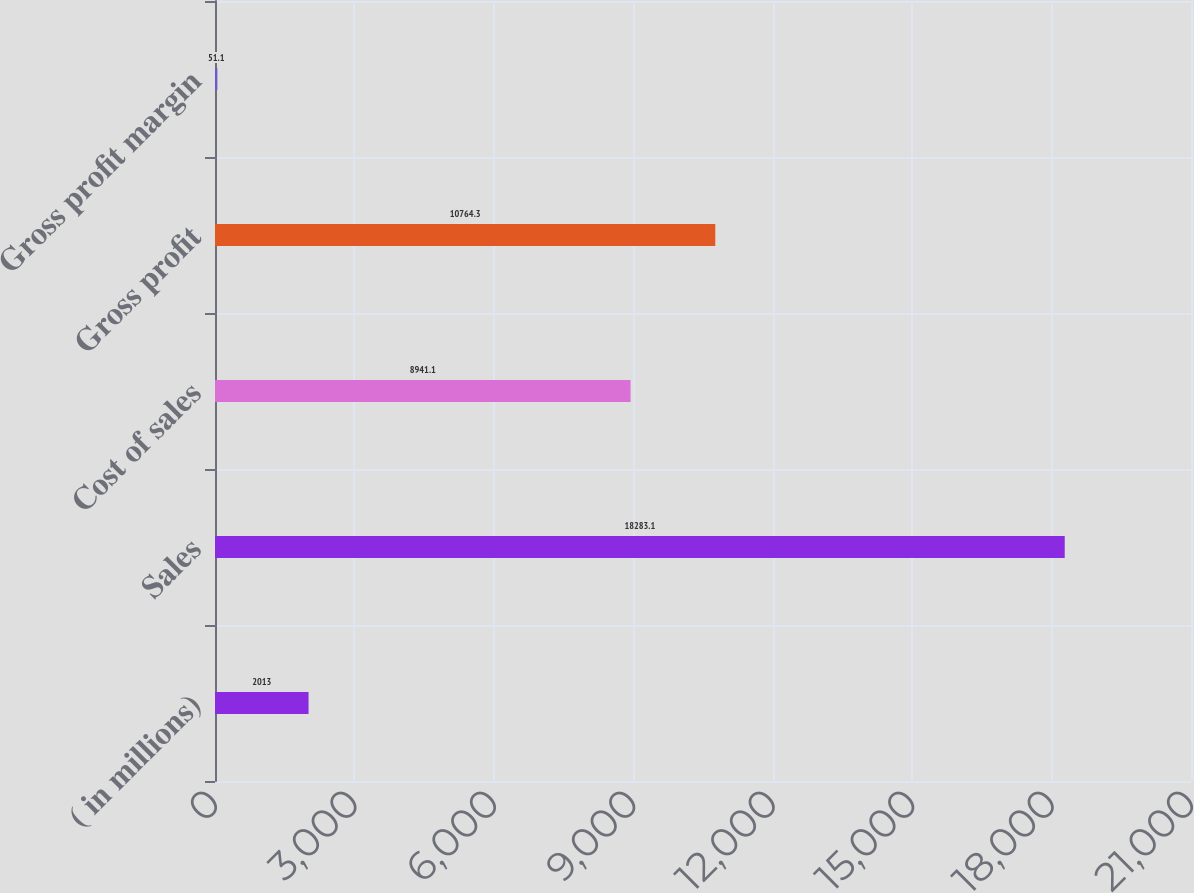Convert chart to OTSL. <chart><loc_0><loc_0><loc_500><loc_500><bar_chart><fcel>( in millions)<fcel>Sales<fcel>Cost of sales<fcel>Gross profit<fcel>Gross profit margin<nl><fcel>2013<fcel>18283.1<fcel>8941.1<fcel>10764.3<fcel>51.1<nl></chart> 